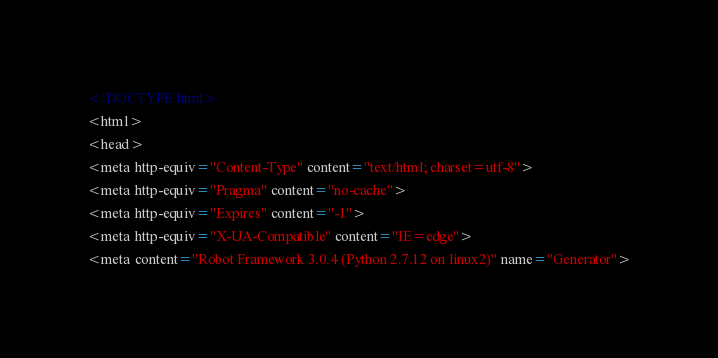Convert code to text. <code><loc_0><loc_0><loc_500><loc_500><_HTML_><!DOCTYPE html>
<html>
<head>
<meta http-equiv="Content-Type" content="text/html; charset=utf-8">
<meta http-equiv="Pragma" content="no-cache">
<meta http-equiv="Expires" content="-1">
<meta http-equiv="X-UA-Compatible" content="IE=edge">
<meta content="Robot Framework 3.0.4 (Python 2.7.12 on linux2)" name="Generator"></code> 